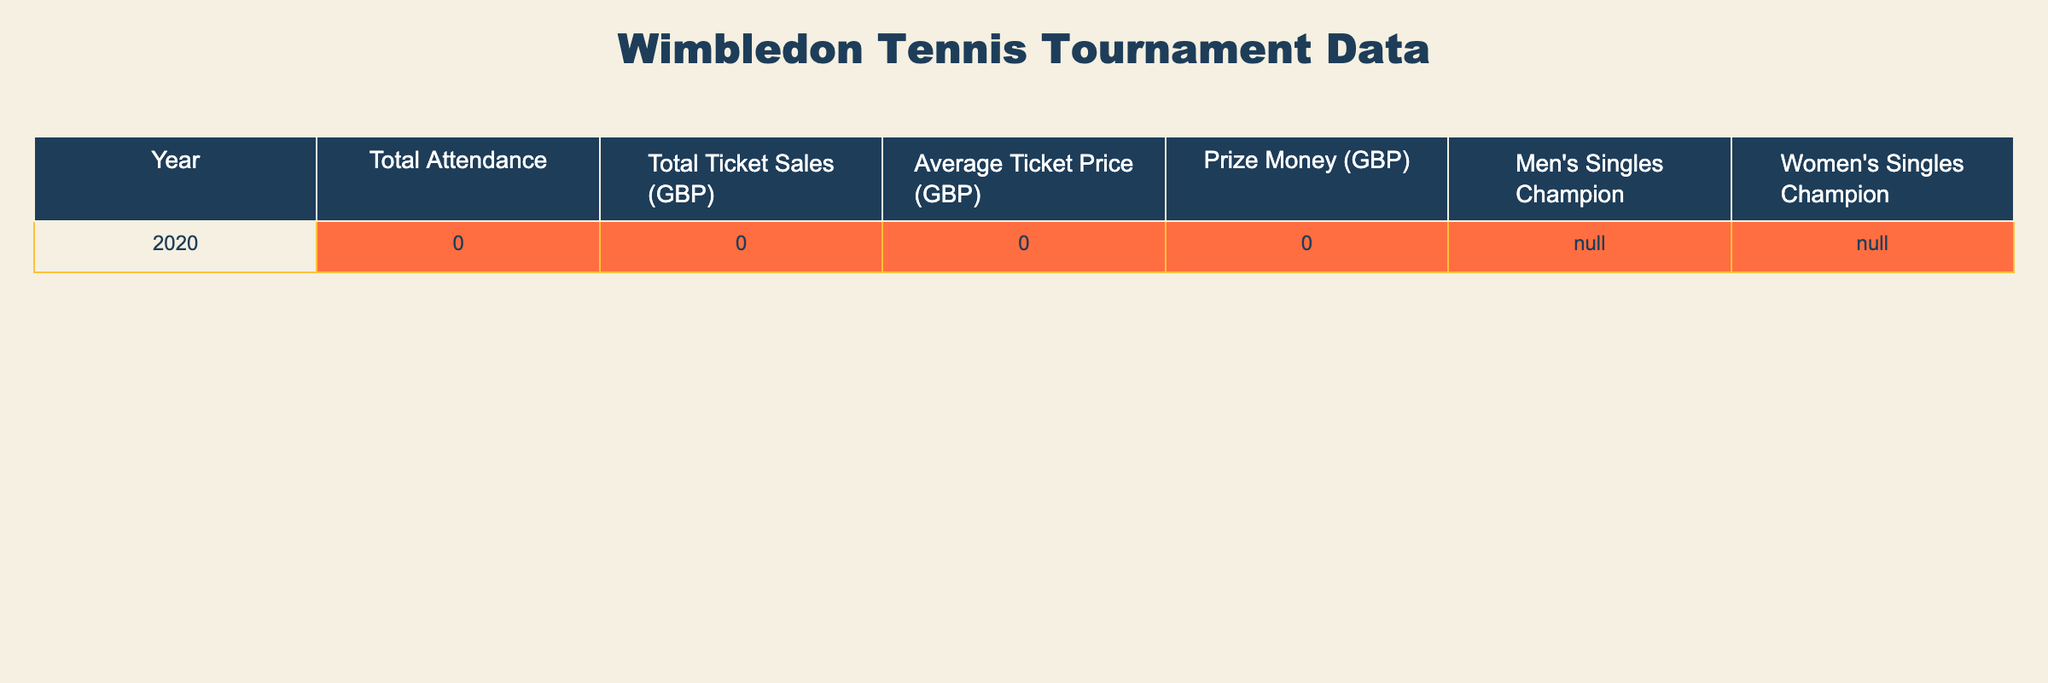What was the total attendance for Wimbledon in 2020? The table indicates that the total attendance for Wimbledon in 2020 was 0. This is clearly stated in the "Total Attendance" column for that year.
Answer: 0 What was the total ticket sales in GBP for Wimbledon in 2020? According to the table, total ticket sales for Wimbledon in 2020 were also 0, as shown in the "Total Ticket Sales (GBP)" column for that year.
Answer: 0 Did Wimbledon have any men's or women's singles champions in 2020? The table states that both the men's and women's singles champions for 2020 are marked as N/A, indicating there were no champions for that year.
Answer: Yes What is the average ticket price in GBP for Wimbledon in 2020? In the table, the average ticket price for Wimbledon in 2020 is recorded as 0 GBP in the "Average Ticket Price (GBP)" column, which reflects no sales occurred that year.
Answer: 0 If we consider the prize money for Wimbledon in 2020, what was it? The table shows that the prize money for Wimbledon in 2020 was 0 GBP as listed in the "Prize Money (GBP)" column for that year.
Answer: 0 Was there a year when both total attendance and ticket sales were non-zero? The table only contains data for the year 2020, which shows that both total attendance and ticket sales were 0. Since there are no other years provided, the answer is no.
Answer: No Is it true that there were any ticket sales in GBP for Wimbledon in 2020? The data in the table indicates that total ticket sales for 2020 was 0 GBP, confirming that there were indeed no ticket sales that year.
Answer: True What can we deduce about the financial performance of Wimbledon in 2020 based on attendance and ticket sales? Since both total attendance and ticket sales are 0, we can deduce that Wimbledon did not generate any revenue from ticket sales or attract any attendees in 2020. This suggests a complete absence of event activity, likely due to external factors such as the COVID-19 pandemic.
Answer: No revenue generated What do the N/A values for champions signify for Wimbledon in 2020? The N/A values for both men's and women's champions suggest that there were no competitions held or winners declared for those categories in 2020, reinforcing the disruption that likely occurred.
Answer: No competitions held 